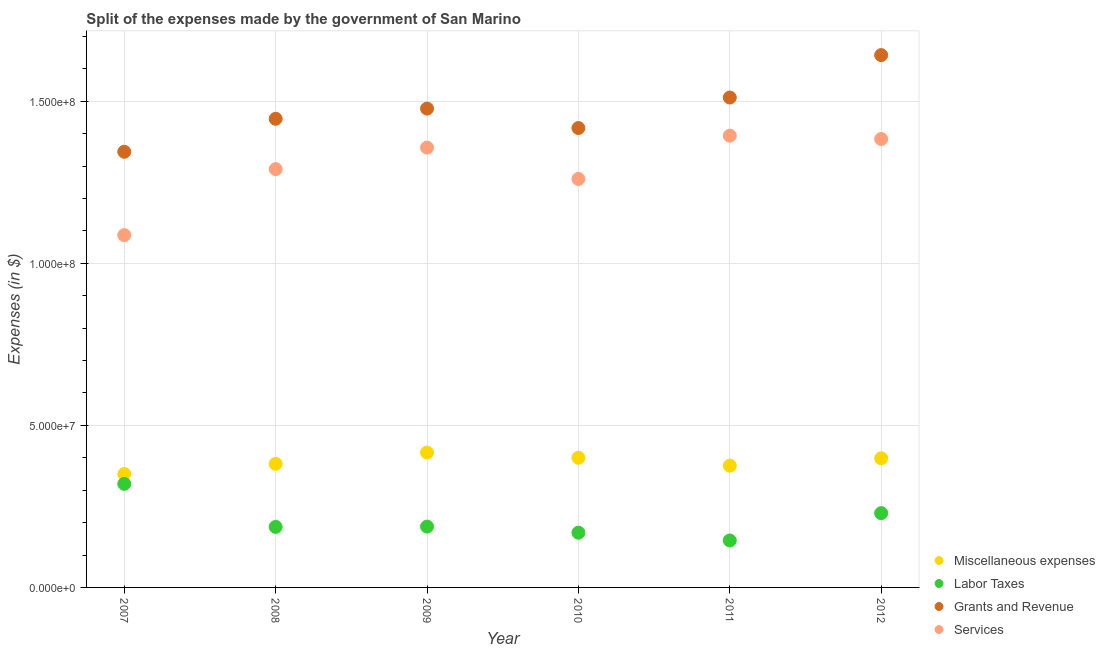Is the number of dotlines equal to the number of legend labels?
Your answer should be compact. Yes. What is the amount spent on services in 2011?
Your response must be concise. 1.39e+08. Across all years, what is the maximum amount spent on miscellaneous expenses?
Ensure brevity in your answer.  4.16e+07. Across all years, what is the minimum amount spent on grants and revenue?
Your answer should be very brief. 1.34e+08. In which year was the amount spent on miscellaneous expenses maximum?
Keep it short and to the point. 2009. What is the total amount spent on labor taxes in the graph?
Your answer should be compact. 1.24e+08. What is the difference between the amount spent on grants and revenue in 2007 and that in 2010?
Your answer should be very brief. -7.32e+06. What is the difference between the amount spent on services in 2009 and the amount spent on miscellaneous expenses in 2008?
Keep it short and to the point. 9.76e+07. What is the average amount spent on services per year?
Provide a short and direct response. 1.30e+08. In the year 2012, what is the difference between the amount spent on grants and revenue and amount spent on services?
Keep it short and to the point. 2.59e+07. In how many years, is the amount spent on services greater than 150000000 $?
Your answer should be compact. 0. What is the ratio of the amount spent on labor taxes in 2008 to that in 2009?
Give a very brief answer. 0.99. Is the difference between the amount spent on grants and revenue in 2008 and 2010 greater than the difference between the amount spent on miscellaneous expenses in 2008 and 2010?
Give a very brief answer. Yes. What is the difference between the highest and the second highest amount spent on miscellaneous expenses?
Ensure brevity in your answer.  1.61e+06. What is the difference between the highest and the lowest amount spent on miscellaneous expenses?
Provide a short and direct response. 6.63e+06. In how many years, is the amount spent on labor taxes greater than the average amount spent on labor taxes taken over all years?
Offer a terse response. 2. Is the sum of the amount spent on grants and revenue in 2010 and 2011 greater than the maximum amount spent on miscellaneous expenses across all years?
Your answer should be compact. Yes. Does the amount spent on labor taxes monotonically increase over the years?
Give a very brief answer. No. How many dotlines are there?
Provide a short and direct response. 4. How many years are there in the graph?
Your response must be concise. 6. What is the difference between two consecutive major ticks on the Y-axis?
Keep it short and to the point. 5.00e+07. Are the values on the major ticks of Y-axis written in scientific E-notation?
Provide a short and direct response. Yes. Does the graph contain any zero values?
Your answer should be compact. No. Where does the legend appear in the graph?
Your response must be concise. Bottom right. How many legend labels are there?
Keep it short and to the point. 4. How are the legend labels stacked?
Your response must be concise. Vertical. What is the title of the graph?
Your answer should be compact. Split of the expenses made by the government of San Marino. Does "Social Protection" appear as one of the legend labels in the graph?
Your response must be concise. No. What is the label or title of the Y-axis?
Give a very brief answer. Expenses (in $). What is the Expenses (in $) in Miscellaneous expenses in 2007?
Offer a terse response. 3.50e+07. What is the Expenses (in $) in Labor Taxes in 2007?
Offer a terse response. 3.20e+07. What is the Expenses (in $) in Grants and Revenue in 2007?
Your answer should be very brief. 1.34e+08. What is the Expenses (in $) of Services in 2007?
Provide a short and direct response. 1.09e+08. What is the Expenses (in $) of Miscellaneous expenses in 2008?
Give a very brief answer. 3.81e+07. What is the Expenses (in $) of Labor Taxes in 2008?
Keep it short and to the point. 1.87e+07. What is the Expenses (in $) in Grants and Revenue in 2008?
Make the answer very short. 1.45e+08. What is the Expenses (in $) in Services in 2008?
Make the answer very short. 1.29e+08. What is the Expenses (in $) of Miscellaneous expenses in 2009?
Give a very brief answer. 4.16e+07. What is the Expenses (in $) in Labor Taxes in 2009?
Ensure brevity in your answer.  1.88e+07. What is the Expenses (in $) in Grants and Revenue in 2009?
Offer a terse response. 1.48e+08. What is the Expenses (in $) of Services in 2009?
Your answer should be very brief. 1.36e+08. What is the Expenses (in $) of Miscellaneous expenses in 2010?
Your answer should be compact. 4.00e+07. What is the Expenses (in $) in Labor Taxes in 2010?
Provide a short and direct response. 1.69e+07. What is the Expenses (in $) in Grants and Revenue in 2010?
Provide a succinct answer. 1.42e+08. What is the Expenses (in $) of Services in 2010?
Your answer should be very brief. 1.26e+08. What is the Expenses (in $) in Miscellaneous expenses in 2011?
Your answer should be very brief. 3.76e+07. What is the Expenses (in $) of Labor Taxes in 2011?
Offer a very short reply. 1.45e+07. What is the Expenses (in $) of Grants and Revenue in 2011?
Offer a very short reply. 1.51e+08. What is the Expenses (in $) in Services in 2011?
Offer a very short reply. 1.39e+08. What is the Expenses (in $) in Miscellaneous expenses in 2012?
Give a very brief answer. 3.99e+07. What is the Expenses (in $) in Labor Taxes in 2012?
Make the answer very short. 2.29e+07. What is the Expenses (in $) of Grants and Revenue in 2012?
Your answer should be compact. 1.64e+08. What is the Expenses (in $) in Services in 2012?
Give a very brief answer. 1.38e+08. Across all years, what is the maximum Expenses (in $) of Miscellaneous expenses?
Ensure brevity in your answer.  4.16e+07. Across all years, what is the maximum Expenses (in $) of Labor Taxes?
Offer a very short reply. 3.20e+07. Across all years, what is the maximum Expenses (in $) of Grants and Revenue?
Your answer should be very brief. 1.64e+08. Across all years, what is the maximum Expenses (in $) of Services?
Offer a terse response. 1.39e+08. Across all years, what is the minimum Expenses (in $) in Miscellaneous expenses?
Give a very brief answer. 3.50e+07. Across all years, what is the minimum Expenses (in $) in Labor Taxes?
Provide a succinct answer. 1.45e+07. Across all years, what is the minimum Expenses (in $) of Grants and Revenue?
Offer a terse response. 1.34e+08. Across all years, what is the minimum Expenses (in $) in Services?
Give a very brief answer. 1.09e+08. What is the total Expenses (in $) in Miscellaneous expenses in the graph?
Your response must be concise. 2.32e+08. What is the total Expenses (in $) in Labor Taxes in the graph?
Provide a succinct answer. 1.24e+08. What is the total Expenses (in $) of Grants and Revenue in the graph?
Provide a succinct answer. 8.84e+08. What is the total Expenses (in $) of Services in the graph?
Ensure brevity in your answer.  7.77e+08. What is the difference between the Expenses (in $) of Miscellaneous expenses in 2007 and that in 2008?
Offer a terse response. -3.15e+06. What is the difference between the Expenses (in $) in Labor Taxes in 2007 and that in 2008?
Your answer should be compact. 1.33e+07. What is the difference between the Expenses (in $) of Grants and Revenue in 2007 and that in 2008?
Give a very brief answer. -1.02e+07. What is the difference between the Expenses (in $) of Services in 2007 and that in 2008?
Your answer should be very brief. -2.04e+07. What is the difference between the Expenses (in $) of Miscellaneous expenses in 2007 and that in 2009?
Your response must be concise. -6.63e+06. What is the difference between the Expenses (in $) of Labor Taxes in 2007 and that in 2009?
Keep it short and to the point. 1.32e+07. What is the difference between the Expenses (in $) in Grants and Revenue in 2007 and that in 2009?
Make the answer very short. -1.33e+07. What is the difference between the Expenses (in $) in Services in 2007 and that in 2009?
Make the answer very short. -2.70e+07. What is the difference between the Expenses (in $) in Miscellaneous expenses in 2007 and that in 2010?
Provide a succinct answer. -5.02e+06. What is the difference between the Expenses (in $) in Labor Taxes in 2007 and that in 2010?
Your answer should be compact. 1.51e+07. What is the difference between the Expenses (in $) in Grants and Revenue in 2007 and that in 2010?
Your answer should be compact. -7.32e+06. What is the difference between the Expenses (in $) in Services in 2007 and that in 2010?
Offer a very short reply. -1.73e+07. What is the difference between the Expenses (in $) of Miscellaneous expenses in 2007 and that in 2011?
Offer a very short reply. -2.58e+06. What is the difference between the Expenses (in $) in Labor Taxes in 2007 and that in 2011?
Offer a very short reply. 1.75e+07. What is the difference between the Expenses (in $) in Grants and Revenue in 2007 and that in 2011?
Ensure brevity in your answer.  -1.67e+07. What is the difference between the Expenses (in $) in Services in 2007 and that in 2011?
Your answer should be very brief. -3.07e+07. What is the difference between the Expenses (in $) in Miscellaneous expenses in 2007 and that in 2012?
Give a very brief answer. -4.86e+06. What is the difference between the Expenses (in $) in Labor Taxes in 2007 and that in 2012?
Your answer should be very brief. 9.05e+06. What is the difference between the Expenses (in $) in Grants and Revenue in 2007 and that in 2012?
Keep it short and to the point. -2.98e+07. What is the difference between the Expenses (in $) of Services in 2007 and that in 2012?
Offer a terse response. -2.97e+07. What is the difference between the Expenses (in $) of Miscellaneous expenses in 2008 and that in 2009?
Your response must be concise. -3.48e+06. What is the difference between the Expenses (in $) in Labor Taxes in 2008 and that in 2009?
Your answer should be very brief. -9.65e+04. What is the difference between the Expenses (in $) in Grants and Revenue in 2008 and that in 2009?
Ensure brevity in your answer.  -3.15e+06. What is the difference between the Expenses (in $) in Services in 2008 and that in 2009?
Offer a terse response. -6.65e+06. What is the difference between the Expenses (in $) in Miscellaneous expenses in 2008 and that in 2010?
Keep it short and to the point. -1.87e+06. What is the difference between the Expenses (in $) of Labor Taxes in 2008 and that in 2010?
Your answer should be very brief. 1.79e+06. What is the difference between the Expenses (in $) of Grants and Revenue in 2008 and that in 2010?
Your answer should be compact. 2.85e+06. What is the difference between the Expenses (in $) in Services in 2008 and that in 2010?
Your response must be concise. 3.03e+06. What is the difference between the Expenses (in $) of Miscellaneous expenses in 2008 and that in 2011?
Give a very brief answer. 5.67e+05. What is the difference between the Expenses (in $) in Labor Taxes in 2008 and that in 2011?
Offer a terse response. 4.20e+06. What is the difference between the Expenses (in $) of Grants and Revenue in 2008 and that in 2011?
Your answer should be very brief. -6.57e+06. What is the difference between the Expenses (in $) of Services in 2008 and that in 2011?
Provide a short and direct response. -1.03e+07. What is the difference between the Expenses (in $) of Miscellaneous expenses in 2008 and that in 2012?
Provide a succinct answer. -1.71e+06. What is the difference between the Expenses (in $) in Labor Taxes in 2008 and that in 2012?
Your answer should be compact. -4.24e+06. What is the difference between the Expenses (in $) of Grants and Revenue in 2008 and that in 2012?
Your answer should be very brief. -1.97e+07. What is the difference between the Expenses (in $) in Services in 2008 and that in 2012?
Offer a very short reply. -9.31e+06. What is the difference between the Expenses (in $) in Miscellaneous expenses in 2009 and that in 2010?
Make the answer very short. 1.61e+06. What is the difference between the Expenses (in $) in Labor Taxes in 2009 and that in 2010?
Make the answer very short. 1.89e+06. What is the difference between the Expenses (in $) in Grants and Revenue in 2009 and that in 2010?
Make the answer very short. 6.01e+06. What is the difference between the Expenses (in $) in Services in 2009 and that in 2010?
Ensure brevity in your answer.  9.68e+06. What is the difference between the Expenses (in $) of Miscellaneous expenses in 2009 and that in 2011?
Keep it short and to the point. 4.05e+06. What is the difference between the Expenses (in $) in Labor Taxes in 2009 and that in 2011?
Your answer should be compact. 4.29e+06. What is the difference between the Expenses (in $) of Grants and Revenue in 2009 and that in 2011?
Ensure brevity in your answer.  -3.42e+06. What is the difference between the Expenses (in $) in Services in 2009 and that in 2011?
Provide a succinct answer. -3.67e+06. What is the difference between the Expenses (in $) of Miscellaneous expenses in 2009 and that in 2012?
Offer a very short reply. 1.77e+06. What is the difference between the Expenses (in $) in Labor Taxes in 2009 and that in 2012?
Make the answer very short. -4.15e+06. What is the difference between the Expenses (in $) in Grants and Revenue in 2009 and that in 2012?
Make the answer very short. -1.65e+07. What is the difference between the Expenses (in $) of Services in 2009 and that in 2012?
Ensure brevity in your answer.  -2.65e+06. What is the difference between the Expenses (in $) in Miscellaneous expenses in 2010 and that in 2011?
Your response must be concise. 2.44e+06. What is the difference between the Expenses (in $) of Labor Taxes in 2010 and that in 2011?
Provide a short and direct response. 2.40e+06. What is the difference between the Expenses (in $) of Grants and Revenue in 2010 and that in 2011?
Your answer should be compact. -9.42e+06. What is the difference between the Expenses (in $) of Services in 2010 and that in 2011?
Offer a very short reply. -1.33e+07. What is the difference between the Expenses (in $) of Miscellaneous expenses in 2010 and that in 2012?
Your response must be concise. 1.60e+05. What is the difference between the Expenses (in $) in Labor Taxes in 2010 and that in 2012?
Offer a terse response. -6.03e+06. What is the difference between the Expenses (in $) of Grants and Revenue in 2010 and that in 2012?
Offer a terse response. -2.25e+07. What is the difference between the Expenses (in $) in Services in 2010 and that in 2012?
Give a very brief answer. -1.23e+07. What is the difference between the Expenses (in $) of Miscellaneous expenses in 2011 and that in 2012?
Provide a short and direct response. -2.28e+06. What is the difference between the Expenses (in $) in Labor Taxes in 2011 and that in 2012?
Your response must be concise. -8.44e+06. What is the difference between the Expenses (in $) of Grants and Revenue in 2011 and that in 2012?
Keep it short and to the point. -1.31e+07. What is the difference between the Expenses (in $) in Services in 2011 and that in 2012?
Provide a succinct answer. 1.01e+06. What is the difference between the Expenses (in $) in Miscellaneous expenses in 2007 and the Expenses (in $) in Labor Taxes in 2008?
Offer a terse response. 1.63e+07. What is the difference between the Expenses (in $) in Miscellaneous expenses in 2007 and the Expenses (in $) in Grants and Revenue in 2008?
Your response must be concise. -1.10e+08. What is the difference between the Expenses (in $) in Miscellaneous expenses in 2007 and the Expenses (in $) in Services in 2008?
Provide a succinct answer. -9.41e+07. What is the difference between the Expenses (in $) in Labor Taxes in 2007 and the Expenses (in $) in Grants and Revenue in 2008?
Offer a terse response. -1.13e+08. What is the difference between the Expenses (in $) of Labor Taxes in 2007 and the Expenses (in $) of Services in 2008?
Provide a short and direct response. -9.71e+07. What is the difference between the Expenses (in $) in Grants and Revenue in 2007 and the Expenses (in $) in Services in 2008?
Keep it short and to the point. 5.36e+06. What is the difference between the Expenses (in $) in Miscellaneous expenses in 2007 and the Expenses (in $) in Labor Taxes in 2009?
Your response must be concise. 1.62e+07. What is the difference between the Expenses (in $) of Miscellaneous expenses in 2007 and the Expenses (in $) of Grants and Revenue in 2009?
Ensure brevity in your answer.  -1.13e+08. What is the difference between the Expenses (in $) of Miscellaneous expenses in 2007 and the Expenses (in $) of Services in 2009?
Your answer should be very brief. -1.01e+08. What is the difference between the Expenses (in $) in Labor Taxes in 2007 and the Expenses (in $) in Grants and Revenue in 2009?
Offer a terse response. -1.16e+08. What is the difference between the Expenses (in $) in Labor Taxes in 2007 and the Expenses (in $) in Services in 2009?
Your answer should be compact. -1.04e+08. What is the difference between the Expenses (in $) in Grants and Revenue in 2007 and the Expenses (in $) in Services in 2009?
Provide a succinct answer. -1.30e+06. What is the difference between the Expenses (in $) of Miscellaneous expenses in 2007 and the Expenses (in $) of Labor Taxes in 2010?
Give a very brief answer. 1.81e+07. What is the difference between the Expenses (in $) in Miscellaneous expenses in 2007 and the Expenses (in $) in Grants and Revenue in 2010?
Keep it short and to the point. -1.07e+08. What is the difference between the Expenses (in $) in Miscellaneous expenses in 2007 and the Expenses (in $) in Services in 2010?
Give a very brief answer. -9.11e+07. What is the difference between the Expenses (in $) in Labor Taxes in 2007 and the Expenses (in $) in Grants and Revenue in 2010?
Provide a short and direct response. -1.10e+08. What is the difference between the Expenses (in $) in Labor Taxes in 2007 and the Expenses (in $) in Services in 2010?
Keep it short and to the point. -9.41e+07. What is the difference between the Expenses (in $) of Grants and Revenue in 2007 and the Expenses (in $) of Services in 2010?
Keep it short and to the point. 8.39e+06. What is the difference between the Expenses (in $) in Miscellaneous expenses in 2007 and the Expenses (in $) in Labor Taxes in 2011?
Give a very brief answer. 2.05e+07. What is the difference between the Expenses (in $) of Miscellaneous expenses in 2007 and the Expenses (in $) of Grants and Revenue in 2011?
Keep it short and to the point. -1.16e+08. What is the difference between the Expenses (in $) in Miscellaneous expenses in 2007 and the Expenses (in $) in Services in 2011?
Your answer should be compact. -1.04e+08. What is the difference between the Expenses (in $) in Labor Taxes in 2007 and the Expenses (in $) in Grants and Revenue in 2011?
Keep it short and to the point. -1.19e+08. What is the difference between the Expenses (in $) of Labor Taxes in 2007 and the Expenses (in $) of Services in 2011?
Give a very brief answer. -1.07e+08. What is the difference between the Expenses (in $) of Grants and Revenue in 2007 and the Expenses (in $) of Services in 2011?
Provide a succinct answer. -4.96e+06. What is the difference between the Expenses (in $) of Miscellaneous expenses in 2007 and the Expenses (in $) of Labor Taxes in 2012?
Offer a terse response. 1.21e+07. What is the difference between the Expenses (in $) in Miscellaneous expenses in 2007 and the Expenses (in $) in Grants and Revenue in 2012?
Make the answer very short. -1.29e+08. What is the difference between the Expenses (in $) of Miscellaneous expenses in 2007 and the Expenses (in $) of Services in 2012?
Offer a very short reply. -1.03e+08. What is the difference between the Expenses (in $) in Labor Taxes in 2007 and the Expenses (in $) in Grants and Revenue in 2012?
Provide a short and direct response. -1.32e+08. What is the difference between the Expenses (in $) in Labor Taxes in 2007 and the Expenses (in $) in Services in 2012?
Ensure brevity in your answer.  -1.06e+08. What is the difference between the Expenses (in $) of Grants and Revenue in 2007 and the Expenses (in $) of Services in 2012?
Provide a short and direct response. -3.95e+06. What is the difference between the Expenses (in $) of Miscellaneous expenses in 2008 and the Expenses (in $) of Labor Taxes in 2009?
Your answer should be compact. 1.94e+07. What is the difference between the Expenses (in $) of Miscellaneous expenses in 2008 and the Expenses (in $) of Grants and Revenue in 2009?
Give a very brief answer. -1.10e+08. What is the difference between the Expenses (in $) in Miscellaneous expenses in 2008 and the Expenses (in $) in Services in 2009?
Give a very brief answer. -9.76e+07. What is the difference between the Expenses (in $) of Labor Taxes in 2008 and the Expenses (in $) of Grants and Revenue in 2009?
Offer a terse response. -1.29e+08. What is the difference between the Expenses (in $) of Labor Taxes in 2008 and the Expenses (in $) of Services in 2009?
Your response must be concise. -1.17e+08. What is the difference between the Expenses (in $) of Grants and Revenue in 2008 and the Expenses (in $) of Services in 2009?
Provide a succinct answer. 8.87e+06. What is the difference between the Expenses (in $) in Miscellaneous expenses in 2008 and the Expenses (in $) in Labor Taxes in 2010?
Offer a terse response. 2.13e+07. What is the difference between the Expenses (in $) of Miscellaneous expenses in 2008 and the Expenses (in $) of Grants and Revenue in 2010?
Provide a succinct answer. -1.04e+08. What is the difference between the Expenses (in $) of Miscellaneous expenses in 2008 and the Expenses (in $) of Services in 2010?
Offer a very short reply. -8.79e+07. What is the difference between the Expenses (in $) in Labor Taxes in 2008 and the Expenses (in $) in Grants and Revenue in 2010?
Your answer should be very brief. -1.23e+08. What is the difference between the Expenses (in $) of Labor Taxes in 2008 and the Expenses (in $) of Services in 2010?
Keep it short and to the point. -1.07e+08. What is the difference between the Expenses (in $) in Grants and Revenue in 2008 and the Expenses (in $) in Services in 2010?
Offer a terse response. 1.86e+07. What is the difference between the Expenses (in $) in Miscellaneous expenses in 2008 and the Expenses (in $) in Labor Taxes in 2011?
Your answer should be very brief. 2.37e+07. What is the difference between the Expenses (in $) of Miscellaneous expenses in 2008 and the Expenses (in $) of Grants and Revenue in 2011?
Provide a short and direct response. -1.13e+08. What is the difference between the Expenses (in $) in Miscellaneous expenses in 2008 and the Expenses (in $) in Services in 2011?
Provide a short and direct response. -1.01e+08. What is the difference between the Expenses (in $) in Labor Taxes in 2008 and the Expenses (in $) in Grants and Revenue in 2011?
Provide a succinct answer. -1.33e+08. What is the difference between the Expenses (in $) in Labor Taxes in 2008 and the Expenses (in $) in Services in 2011?
Your answer should be very brief. -1.21e+08. What is the difference between the Expenses (in $) of Grants and Revenue in 2008 and the Expenses (in $) of Services in 2011?
Provide a short and direct response. 5.21e+06. What is the difference between the Expenses (in $) of Miscellaneous expenses in 2008 and the Expenses (in $) of Labor Taxes in 2012?
Ensure brevity in your answer.  1.52e+07. What is the difference between the Expenses (in $) in Miscellaneous expenses in 2008 and the Expenses (in $) in Grants and Revenue in 2012?
Make the answer very short. -1.26e+08. What is the difference between the Expenses (in $) of Miscellaneous expenses in 2008 and the Expenses (in $) of Services in 2012?
Keep it short and to the point. -1.00e+08. What is the difference between the Expenses (in $) in Labor Taxes in 2008 and the Expenses (in $) in Grants and Revenue in 2012?
Offer a terse response. -1.46e+08. What is the difference between the Expenses (in $) of Labor Taxes in 2008 and the Expenses (in $) of Services in 2012?
Make the answer very short. -1.20e+08. What is the difference between the Expenses (in $) of Grants and Revenue in 2008 and the Expenses (in $) of Services in 2012?
Provide a short and direct response. 6.22e+06. What is the difference between the Expenses (in $) of Miscellaneous expenses in 2009 and the Expenses (in $) of Labor Taxes in 2010?
Ensure brevity in your answer.  2.47e+07. What is the difference between the Expenses (in $) in Miscellaneous expenses in 2009 and the Expenses (in $) in Grants and Revenue in 2010?
Ensure brevity in your answer.  -1.00e+08. What is the difference between the Expenses (in $) of Miscellaneous expenses in 2009 and the Expenses (in $) of Services in 2010?
Your response must be concise. -8.44e+07. What is the difference between the Expenses (in $) in Labor Taxes in 2009 and the Expenses (in $) in Grants and Revenue in 2010?
Make the answer very short. -1.23e+08. What is the difference between the Expenses (in $) of Labor Taxes in 2009 and the Expenses (in $) of Services in 2010?
Your answer should be compact. -1.07e+08. What is the difference between the Expenses (in $) in Grants and Revenue in 2009 and the Expenses (in $) in Services in 2010?
Your response must be concise. 2.17e+07. What is the difference between the Expenses (in $) in Miscellaneous expenses in 2009 and the Expenses (in $) in Labor Taxes in 2011?
Make the answer very short. 2.71e+07. What is the difference between the Expenses (in $) in Miscellaneous expenses in 2009 and the Expenses (in $) in Grants and Revenue in 2011?
Provide a short and direct response. -1.10e+08. What is the difference between the Expenses (in $) of Miscellaneous expenses in 2009 and the Expenses (in $) of Services in 2011?
Offer a very short reply. -9.78e+07. What is the difference between the Expenses (in $) in Labor Taxes in 2009 and the Expenses (in $) in Grants and Revenue in 2011?
Keep it short and to the point. -1.32e+08. What is the difference between the Expenses (in $) of Labor Taxes in 2009 and the Expenses (in $) of Services in 2011?
Your response must be concise. -1.21e+08. What is the difference between the Expenses (in $) of Grants and Revenue in 2009 and the Expenses (in $) of Services in 2011?
Keep it short and to the point. 8.36e+06. What is the difference between the Expenses (in $) in Miscellaneous expenses in 2009 and the Expenses (in $) in Labor Taxes in 2012?
Keep it short and to the point. 1.87e+07. What is the difference between the Expenses (in $) of Miscellaneous expenses in 2009 and the Expenses (in $) of Grants and Revenue in 2012?
Provide a short and direct response. -1.23e+08. What is the difference between the Expenses (in $) of Miscellaneous expenses in 2009 and the Expenses (in $) of Services in 2012?
Ensure brevity in your answer.  -9.68e+07. What is the difference between the Expenses (in $) in Labor Taxes in 2009 and the Expenses (in $) in Grants and Revenue in 2012?
Your response must be concise. -1.46e+08. What is the difference between the Expenses (in $) in Labor Taxes in 2009 and the Expenses (in $) in Services in 2012?
Ensure brevity in your answer.  -1.20e+08. What is the difference between the Expenses (in $) in Grants and Revenue in 2009 and the Expenses (in $) in Services in 2012?
Provide a succinct answer. 9.37e+06. What is the difference between the Expenses (in $) of Miscellaneous expenses in 2010 and the Expenses (in $) of Labor Taxes in 2011?
Provide a short and direct response. 2.55e+07. What is the difference between the Expenses (in $) in Miscellaneous expenses in 2010 and the Expenses (in $) in Grants and Revenue in 2011?
Your answer should be very brief. -1.11e+08. What is the difference between the Expenses (in $) of Miscellaneous expenses in 2010 and the Expenses (in $) of Services in 2011?
Offer a very short reply. -9.94e+07. What is the difference between the Expenses (in $) of Labor Taxes in 2010 and the Expenses (in $) of Grants and Revenue in 2011?
Provide a short and direct response. -1.34e+08. What is the difference between the Expenses (in $) of Labor Taxes in 2010 and the Expenses (in $) of Services in 2011?
Offer a terse response. -1.23e+08. What is the difference between the Expenses (in $) in Grants and Revenue in 2010 and the Expenses (in $) in Services in 2011?
Keep it short and to the point. 2.35e+06. What is the difference between the Expenses (in $) of Miscellaneous expenses in 2010 and the Expenses (in $) of Labor Taxes in 2012?
Provide a succinct answer. 1.71e+07. What is the difference between the Expenses (in $) of Miscellaneous expenses in 2010 and the Expenses (in $) of Grants and Revenue in 2012?
Your answer should be very brief. -1.24e+08. What is the difference between the Expenses (in $) in Miscellaneous expenses in 2010 and the Expenses (in $) in Services in 2012?
Offer a very short reply. -9.84e+07. What is the difference between the Expenses (in $) of Labor Taxes in 2010 and the Expenses (in $) of Grants and Revenue in 2012?
Keep it short and to the point. -1.47e+08. What is the difference between the Expenses (in $) of Labor Taxes in 2010 and the Expenses (in $) of Services in 2012?
Keep it short and to the point. -1.22e+08. What is the difference between the Expenses (in $) of Grants and Revenue in 2010 and the Expenses (in $) of Services in 2012?
Make the answer very short. 3.37e+06. What is the difference between the Expenses (in $) of Miscellaneous expenses in 2011 and the Expenses (in $) of Labor Taxes in 2012?
Your answer should be very brief. 1.47e+07. What is the difference between the Expenses (in $) of Miscellaneous expenses in 2011 and the Expenses (in $) of Grants and Revenue in 2012?
Your answer should be compact. -1.27e+08. What is the difference between the Expenses (in $) of Miscellaneous expenses in 2011 and the Expenses (in $) of Services in 2012?
Offer a terse response. -1.01e+08. What is the difference between the Expenses (in $) in Labor Taxes in 2011 and the Expenses (in $) in Grants and Revenue in 2012?
Give a very brief answer. -1.50e+08. What is the difference between the Expenses (in $) of Labor Taxes in 2011 and the Expenses (in $) of Services in 2012?
Ensure brevity in your answer.  -1.24e+08. What is the difference between the Expenses (in $) in Grants and Revenue in 2011 and the Expenses (in $) in Services in 2012?
Provide a succinct answer. 1.28e+07. What is the average Expenses (in $) of Miscellaneous expenses per year?
Provide a short and direct response. 3.87e+07. What is the average Expenses (in $) of Labor Taxes per year?
Provide a short and direct response. 2.06e+07. What is the average Expenses (in $) in Grants and Revenue per year?
Ensure brevity in your answer.  1.47e+08. What is the average Expenses (in $) of Services per year?
Make the answer very short. 1.30e+08. In the year 2007, what is the difference between the Expenses (in $) in Miscellaneous expenses and Expenses (in $) in Labor Taxes?
Provide a succinct answer. 3.02e+06. In the year 2007, what is the difference between the Expenses (in $) in Miscellaneous expenses and Expenses (in $) in Grants and Revenue?
Your answer should be compact. -9.95e+07. In the year 2007, what is the difference between the Expenses (in $) of Miscellaneous expenses and Expenses (in $) of Services?
Your answer should be very brief. -7.37e+07. In the year 2007, what is the difference between the Expenses (in $) of Labor Taxes and Expenses (in $) of Grants and Revenue?
Give a very brief answer. -1.02e+08. In the year 2007, what is the difference between the Expenses (in $) of Labor Taxes and Expenses (in $) of Services?
Your answer should be compact. -7.68e+07. In the year 2007, what is the difference between the Expenses (in $) in Grants and Revenue and Expenses (in $) in Services?
Provide a succinct answer. 2.57e+07. In the year 2008, what is the difference between the Expenses (in $) in Miscellaneous expenses and Expenses (in $) in Labor Taxes?
Offer a very short reply. 1.95e+07. In the year 2008, what is the difference between the Expenses (in $) in Miscellaneous expenses and Expenses (in $) in Grants and Revenue?
Offer a terse response. -1.06e+08. In the year 2008, what is the difference between the Expenses (in $) of Miscellaneous expenses and Expenses (in $) of Services?
Offer a very short reply. -9.09e+07. In the year 2008, what is the difference between the Expenses (in $) of Labor Taxes and Expenses (in $) of Grants and Revenue?
Give a very brief answer. -1.26e+08. In the year 2008, what is the difference between the Expenses (in $) of Labor Taxes and Expenses (in $) of Services?
Offer a terse response. -1.10e+08. In the year 2008, what is the difference between the Expenses (in $) of Grants and Revenue and Expenses (in $) of Services?
Your answer should be very brief. 1.55e+07. In the year 2009, what is the difference between the Expenses (in $) of Miscellaneous expenses and Expenses (in $) of Labor Taxes?
Your answer should be very brief. 2.28e+07. In the year 2009, what is the difference between the Expenses (in $) in Miscellaneous expenses and Expenses (in $) in Grants and Revenue?
Keep it short and to the point. -1.06e+08. In the year 2009, what is the difference between the Expenses (in $) of Miscellaneous expenses and Expenses (in $) of Services?
Your answer should be compact. -9.41e+07. In the year 2009, what is the difference between the Expenses (in $) of Labor Taxes and Expenses (in $) of Grants and Revenue?
Keep it short and to the point. -1.29e+08. In the year 2009, what is the difference between the Expenses (in $) of Labor Taxes and Expenses (in $) of Services?
Your response must be concise. -1.17e+08. In the year 2009, what is the difference between the Expenses (in $) in Grants and Revenue and Expenses (in $) in Services?
Provide a short and direct response. 1.20e+07. In the year 2010, what is the difference between the Expenses (in $) in Miscellaneous expenses and Expenses (in $) in Labor Taxes?
Your response must be concise. 2.31e+07. In the year 2010, what is the difference between the Expenses (in $) in Miscellaneous expenses and Expenses (in $) in Grants and Revenue?
Provide a succinct answer. -1.02e+08. In the year 2010, what is the difference between the Expenses (in $) of Miscellaneous expenses and Expenses (in $) of Services?
Offer a very short reply. -8.60e+07. In the year 2010, what is the difference between the Expenses (in $) in Labor Taxes and Expenses (in $) in Grants and Revenue?
Offer a very short reply. -1.25e+08. In the year 2010, what is the difference between the Expenses (in $) in Labor Taxes and Expenses (in $) in Services?
Offer a very short reply. -1.09e+08. In the year 2010, what is the difference between the Expenses (in $) of Grants and Revenue and Expenses (in $) of Services?
Give a very brief answer. 1.57e+07. In the year 2011, what is the difference between the Expenses (in $) in Miscellaneous expenses and Expenses (in $) in Labor Taxes?
Your answer should be compact. 2.31e+07. In the year 2011, what is the difference between the Expenses (in $) of Miscellaneous expenses and Expenses (in $) of Grants and Revenue?
Keep it short and to the point. -1.14e+08. In the year 2011, what is the difference between the Expenses (in $) of Miscellaneous expenses and Expenses (in $) of Services?
Keep it short and to the point. -1.02e+08. In the year 2011, what is the difference between the Expenses (in $) in Labor Taxes and Expenses (in $) in Grants and Revenue?
Make the answer very short. -1.37e+08. In the year 2011, what is the difference between the Expenses (in $) of Labor Taxes and Expenses (in $) of Services?
Ensure brevity in your answer.  -1.25e+08. In the year 2011, what is the difference between the Expenses (in $) in Grants and Revenue and Expenses (in $) in Services?
Give a very brief answer. 1.18e+07. In the year 2012, what is the difference between the Expenses (in $) of Miscellaneous expenses and Expenses (in $) of Labor Taxes?
Give a very brief answer. 1.69e+07. In the year 2012, what is the difference between the Expenses (in $) of Miscellaneous expenses and Expenses (in $) of Grants and Revenue?
Provide a short and direct response. -1.24e+08. In the year 2012, what is the difference between the Expenses (in $) of Miscellaneous expenses and Expenses (in $) of Services?
Make the answer very short. -9.85e+07. In the year 2012, what is the difference between the Expenses (in $) in Labor Taxes and Expenses (in $) in Grants and Revenue?
Offer a very short reply. -1.41e+08. In the year 2012, what is the difference between the Expenses (in $) of Labor Taxes and Expenses (in $) of Services?
Your answer should be compact. -1.15e+08. In the year 2012, what is the difference between the Expenses (in $) of Grants and Revenue and Expenses (in $) of Services?
Your answer should be very brief. 2.59e+07. What is the ratio of the Expenses (in $) in Miscellaneous expenses in 2007 to that in 2008?
Give a very brief answer. 0.92. What is the ratio of the Expenses (in $) in Labor Taxes in 2007 to that in 2008?
Your response must be concise. 1.71. What is the ratio of the Expenses (in $) in Grants and Revenue in 2007 to that in 2008?
Offer a very short reply. 0.93. What is the ratio of the Expenses (in $) of Services in 2007 to that in 2008?
Provide a short and direct response. 0.84. What is the ratio of the Expenses (in $) of Miscellaneous expenses in 2007 to that in 2009?
Make the answer very short. 0.84. What is the ratio of the Expenses (in $) of Labor Taxes in 2007 to that in 2009?
Offer a very short reply. 1.7. What is the ratio of the Expenses (in $) in Grants and Revenue in 2007 to that in 2009?
Ensure brevity in your answer.  0.91. What is the ratio of the Expenses (in $) of Services in 2007 to that in 2009?
Ensure brevity in your answer.  0.8. What is the ratio of the Expenses (in $) of Miscellaneous expenses in 2007 to that in 2010?
Make the answer very short. 0.87. What is the ratio of the Expenses (in $) in Labor Taxes in 2007 to that in 2010?
Your answer should be very brief. 1.89. What is the ratio of the Expenses (in $) of Grants and Revenue in 2007 to that in 2010?
Provide a short and direct response. 0.95. What is the ratio of the Expenses (in $) in Services in 2007 to that in 2010?
Ensure brevity in your answer.  0.86. What is the ratio of the Expenses (in $) in Miscellaneous expenses in 2007 to that in 2011?
Provide a short and direct response. 0.93. What is the ratio of the Expenses (in $) of Labor Taxes in 2007 to that in 2011?
Give a very brief answer. 2.21. What is the ratio of the Expenses (in $) in Grants and Revenue in 2007 to that in 2011?
Offer a very short reply. 0.89. What is the ratio of the Expenses (in $) in Services in 2007 to that in 2011?
Provide a short and direct response. 0.78. What is the ratio of the Expenses (in $) in Miscellaneous expenses in 2007 to that in 2012?
Your answer should be very brief. 0.88. What is the ratio of the Expenses (in $) in Labor Taxes in 2007 to that in 2012?
Provide a short and direct response. 1.39. What is the ratio of the Expenses (in $) in Grants and Revenue in 2007 to that in 2012?
Your answer should be compact. 0.82. What is the ratio of the Expenses (in $) in Services in 2007 to that in 2012?
Your answer should be compact. 0.79. What is the ratio of the Expenses (in $) of Miscellaneous expenses in 2008 to that in 2009?
Provide a succinct answer. 0.92. What is the ratio of the Expenses (in $) in Grants and Revenue in 2008 to that in 2009?
Your answer should be very brief. 0.98. What is the ratio of the Expenses (in $) in Services in 2008 to that in 2009?
Your response must be concise. 0.95. What is the ratio of the Expenses (in $) of Miscellaneous expenses in 2008 to that in 2010?
Provide a succinct answer. 0.95. What is the ratio of the Expenses (in $) in Labor Taxes in 2008 to that in 2010?
Offer a very short reply. 1.11. What is the ratio of the Expenses (in $) in Grants and Revenue in 2008 to that in 2010?
Make the answer very short. 1.02. What is the ratio of the Expenses (in $) of Miscellaneous expenses in 2008 to that in 2011?
Offer a terse response. 1.02. What is the ratio of the Expenses (in $) of Labor Taxes in 2008 to that in 2011?
Provide a succinct answer. 1.29. What is the ratio of the Expenses (in $) in Grants and Revenue in 2008 to that in 2011?
Provide a short and direct response. 0.96. What is the ratio of the Expenses (in $) in Services in 2008 to that in 2011?
Ensure brevity in your answer.  0.93. What is the ratio of the Expenses (in $) in Miscellaneous expenses in 2008 to that in 2012?
Provide a short and direct response. 0.96. What is the ratio of the Expenses (in $) in Labor Taxes in 2008 to that in 2012?
Keep it short and to the point. 0.81. What is the ratio of the Expenses (in $) in Grants and Revenue in 2008 to that in 2012?
Provide a short and direct response. 0.88. What is the ratio of the Expenses (in $) in Services in 2008 to that in 2012?
Give a very brief answer. 0.93. What is the ratio of the Expenses (in $) in Miscellaneous expenses in 2009 to that in 2010?
Keep it short and to the point. 1.04. What is the ratio of the Expenses (in $) of Labor Taxes in 2009 to that in 2010?
Give a very brief answer. 1.11. What is the ratio of the Expenses (in $) in Grants and Revenue in 2009 to that in 2010?
Provide a succinct answer. 1.04. What is the ratio of the Expenses (in $) in Services in 2009 to that in 2010?
Your answer should be compact. 1.08. What is the ratio of the Expenses (in $) in Miscellaneous expenses in 2009 to that in 2011?
Your answer should be very brief. 1.11. What is the ratio of the Expenses (in $) in Labor Taxes in 2009 to that in 2011?
Your answer should be very brief. 1.3. What is the ratio of the Expenses (in $) in Grants and Revenue in 2009 to that in 2011?
Give a very brief answer. 0.98. What is the ratio of the Expenses (in $) in Services in 2009 to that in 2011?
Provide a short and direct response. 0.97. What is the ratio of the Expenses (in $) of Miscellaneous expenses in 2009 to that in 2012?
Ensure brevity in your answer.  1.04. What is the ratio of the Expenses (in $) of Labor Taxes in 2009 to that in 2012?
Give a very brief answer. 0.82. What is the ratio of the Expenses (in $) of Grants and Revenue in 2009 to that in 2012?
Your answer should be very brief. 0.9. What is the ratio of the Expenses (in $) of Services in 2009 to that in 2012?
Provide a succinct answer. 0.98. What is the ratio of the Expenses (in $) of Miscellaneous expenses in 2010 to that in 2011?
Provide a succinct answer. 1.06. What is the ratio of the Expenses (in $) of Labor Taxes in 2010 to that in 2011?
Your response must be concise. 1.17. What is the ratio of the Expenses (in $) in Grants and Revenue in 2010 to that in 2011?
Provide a short and direct response. 0.94. What is the ratio of the Expenses (in $) in Services in 2010 to that in 2011?
Your answer should be very brief. 0.9. What is the ratio of the Expenses (in $) of Miscellaneous expenses in 2010 to that in 2012?
Your answer should be very brief. 1. What is the ratio of the Expenses (in $) of Labor Taxes in 2010 to that in 2012?
Offer a very short reply. 0.74. What is the ratio of the Expenses (in $) in Grants and Revenue in 2010 to that in 2012?
Your answer should be compact. 0.86. What is the ratio of the Expenses (in $) of Services in 2010 to that in 2012?
Your answer should be very brief. 0.91. What is the ratio of the Expenses (in $) of Miscellaneous expenses in 2011 to that in 2012?
Your answer should be very brief. 0.94. What is the ratio of the Expenses (in $) in Labor Taxes in 2011 to that in 2012?
Ensure brevity in your answer.  0.63. What is the ratio of the Expenses (in $) of Grants and Revenue in 2011 to that in 2012?
Offer a terse response. 0.92. What is the ratio of the Expenses (in $) of Services in 2011 to that in 2012?
Offer a very short reply. 1.01. What is the difference between the highest and the second highest Expenses (in $) of Miscellaneous expenses?
Your response must be concise. 1.61e+06. What is the difference between the highest and the second highest Expenses (in $) of Labor Taxes?
Make the answer very short. 9.05e+06. What is the difference between the highest and the second highest Expenses (in $) of Grants and Revenue?
Keep it short and to the point. 1.31e+07. What is the difference between the highest and the second highest Expenses (in $) in Services?
Offer a very short reply. 1.01e+06. What is the difference between the highest and the lowest Expenses (in $) in Miscellaneous expenses?
Your answer should be compact. 6.63e+06. What is the difference between the highest and the lowest Expenses (in $) of Labor Taxes?
Offer a very short reply. 1.75e+07. What is the difference between the highest and the lowest Expenses (in $) of Grants and Revenue?
Keep it short and to the point. 2.98e+07. What is the difference between the highest and the lowest Expenses (in $) of Services?
Your answer should be very brief. 3.07e+07. 